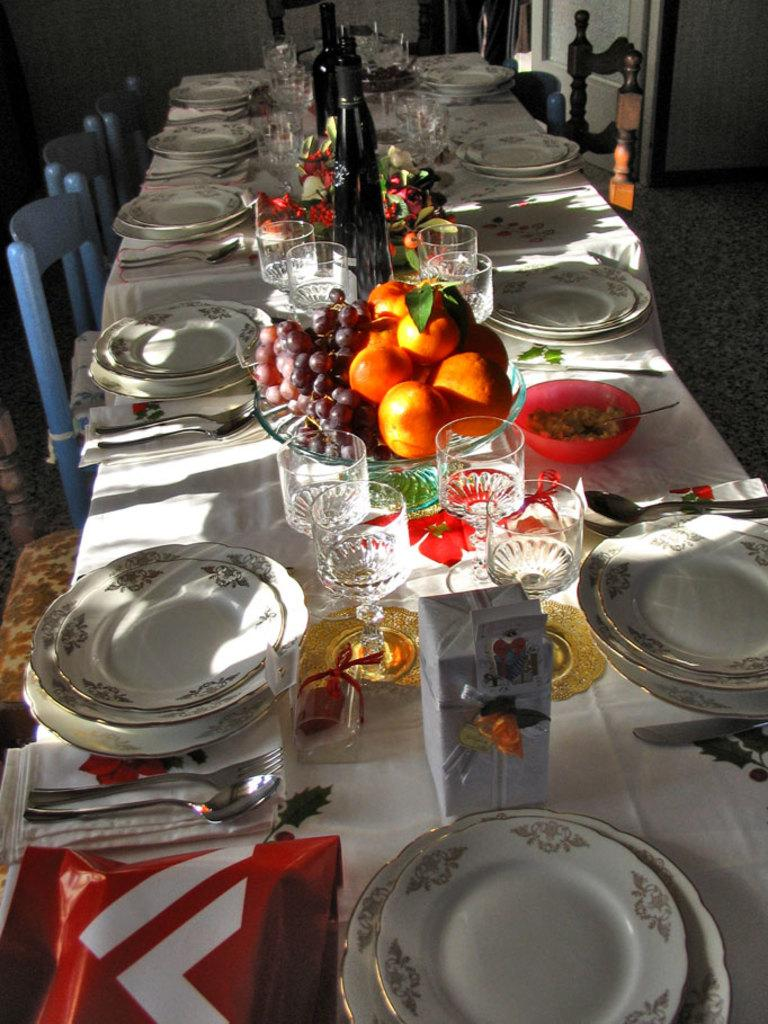What is on the plate that is visible in the image? There are no specific details about the contents of the plate in the provided facts. Besides the plate, what other items can be seen in the image? There are glasses and fruits visible in the image. Where are the objects located in the image? The objects are on a dining table. What is on the left side of the image? There are chairs on the left side of the image. What type of knee injury can be seen in the image? There is no mention of a knee or any injury in the provided facts, so it cannot be determined from the image. 